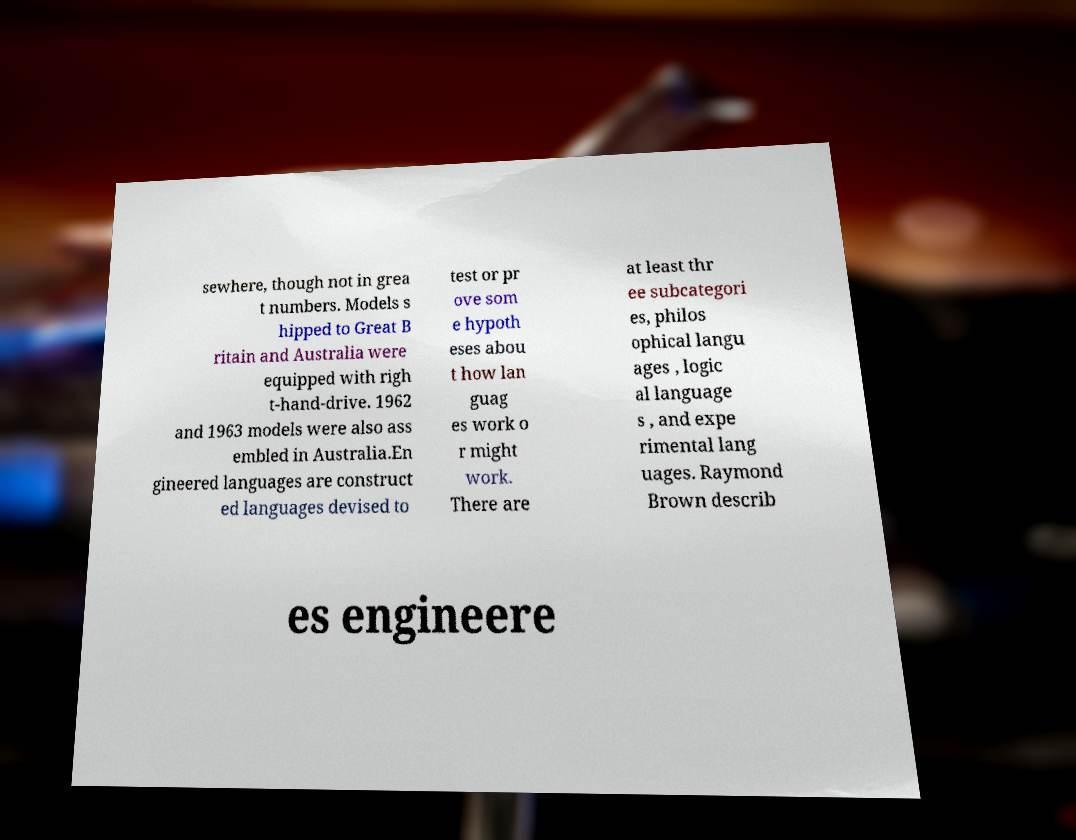I need the written content from this picture converted into text. Can you do that? sewhere, though not in grea t numbers. Models s hipped to Great B ritain and Australia were equipped with righ t-hand-drive. 1962 and 1963 models were also ass embled in Australia.En gineered languages are construct ed languages devised to test or pr ove som e hypoth eses abou t how lan guag es work o r might work. There are at least thr ee subcategori es, philos ophical langu ages , logic al language s , and expe rimental lang uages. Raymond Brown describ es engineere 